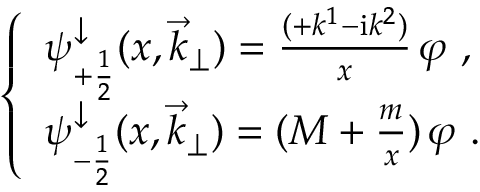<formula> <loc_0><loc_0><loc_500><loc_500>\left \{ \begin{array} { l } { { \psi _ { + \frac { 1 } { 2 } } ^ { \downarrow } ( x , { \vec { k } } _ { \perp } ) = \frac { ( + k ^ { 1 } - { \mathrm i } k ^ { 2 } ) } { x } \, \varphi \ , } } \\ { { \psi _ { - \frac { 1 } { 2 } } ^ { \downarrow } ( x , { \vec { k } } _ { \perp } ) = ( M + \frac { m } { x } ) \, \varphi \ . } } \end{array}</formula> 